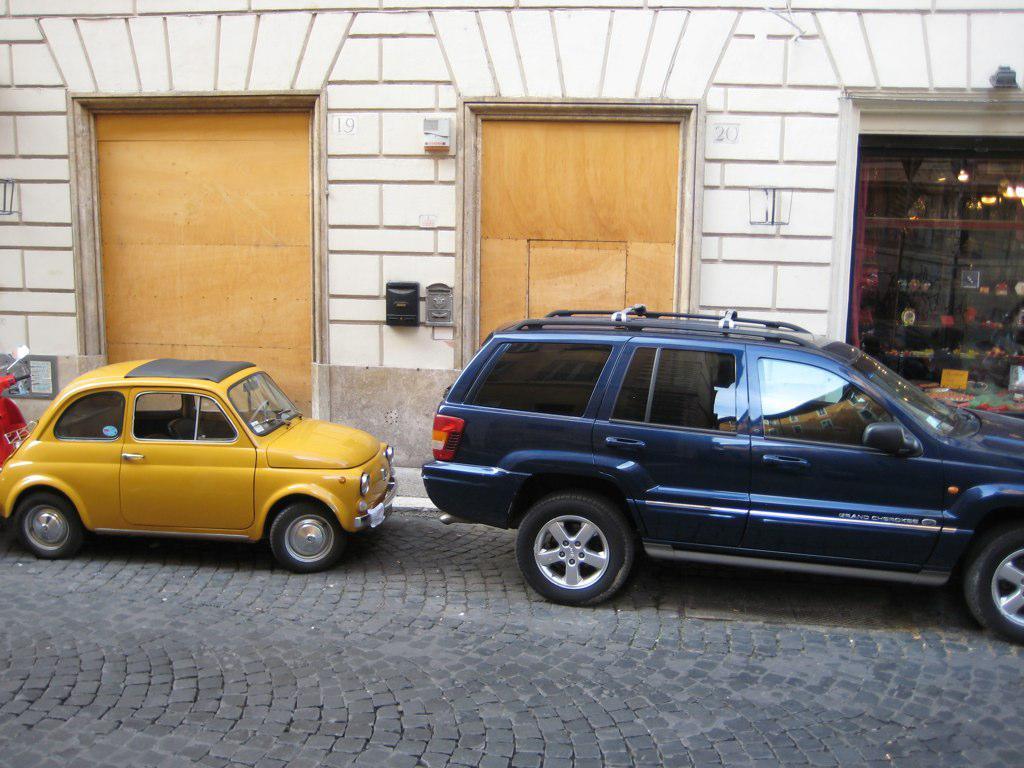Describe this image in one or two sentences. This image is taken outdoors. At the bottom of the image there is a road. In the background there is a building with a wall, doors, switch boards and a store with many things in it. In the middle of the image two cars and a bike are parked on the road. 